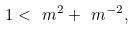Convert formula to latex. <formula><loc_0><loc_0><loc_500><loc_500>1 < \ m ^ { 2 } + \ m ^ { - 2 } ,</formula> 